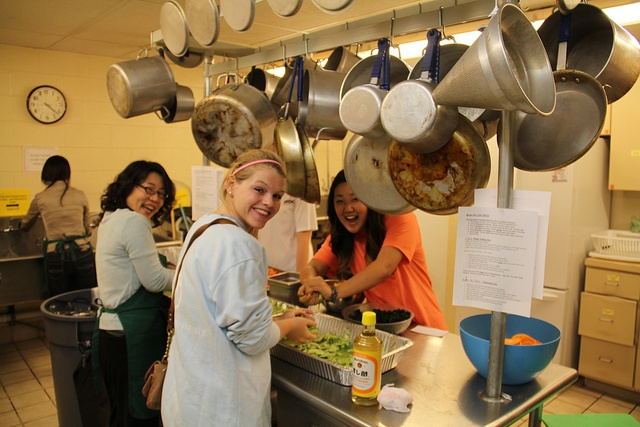Describe the objects in this image and their specific colors. I can see dining table in olive, black, tan, and blue tones, people in olive, darkgray, lightgray, brown, and tan tones, people in olive, black, tan, and gray tones, people in olive, black, red, brown, and maroon tones, and refrigerator in olive and tan tones in this image. 